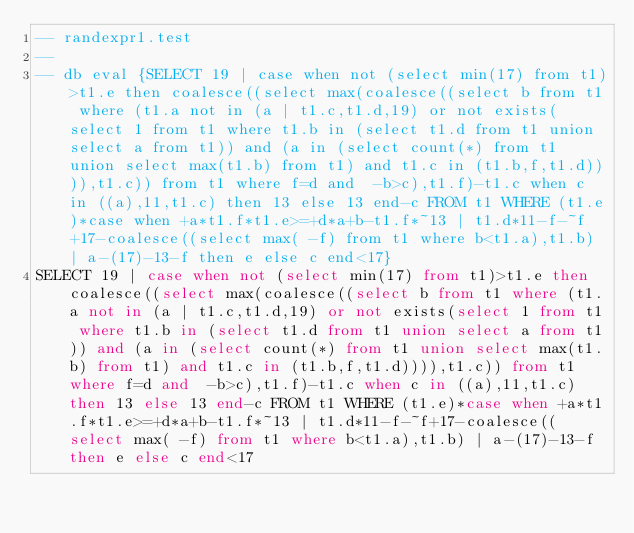<code> <loc_0><loc_0><loc_500><loc_500><_SQL_>-- randexpr1.test
-- 
-- db eval {SELECT 19 | case when not (select min(17) from t1)>t1.e then coalesce((select max(coalesce((select b from t1 where (t1.a not in (a | t1.c,t1.d,19) or not exists(select 1 from t1 where t1.b in (select t1.d from t1 union select a from t1)) and (a in (select count(*) from t1 union select max(t1.b) from t1) and t1.c in (t1.b,f,t1.d)))),t1.c)) from t1 where f=d and  -b>c),t1.f)-t1.c when c in ((a),11,t1.c) then 13 else 13 end-c FROM t1 WHERE (t1.e)*case when +a*t1.f*t1.e>=+d*a+b-t1.f*~13 | t1.d*11-f-~f+17-coalesce((select max( -f) from t1 where b<t1.a),t1.b) | a-(17)-13-f then e else c end<17}
SELECT 19 | case when not (select min(17) from t1)>t1.e then coalesce((select max(coalesce((select b from t1 where (t1.a not in (a | t1.c,t1.d,19) or not exists(select 1 from t1 where t1.b in (select t1.d from t1 union select a from t1)) and (a in (select count(*) from t1 union select max(t1.b) from t1) and t1.c in (t1.b,f,t1.d)))),t1.c)) from t1 where f=d and  -b>c),t1.f)-t1.c when c in ((a),11,t1.c) then 13 else 13 end-c FROM t1 WHERE (t1.e)*case when +a*t1.f*t1.e>=+d*a+b-t1.f*~13 | t1.d*11-f-~f+17-coalesce((select max( -f) from t1 where b<t1.a),t1.b) | a-(17)-13-f then e else c end<17</code> 